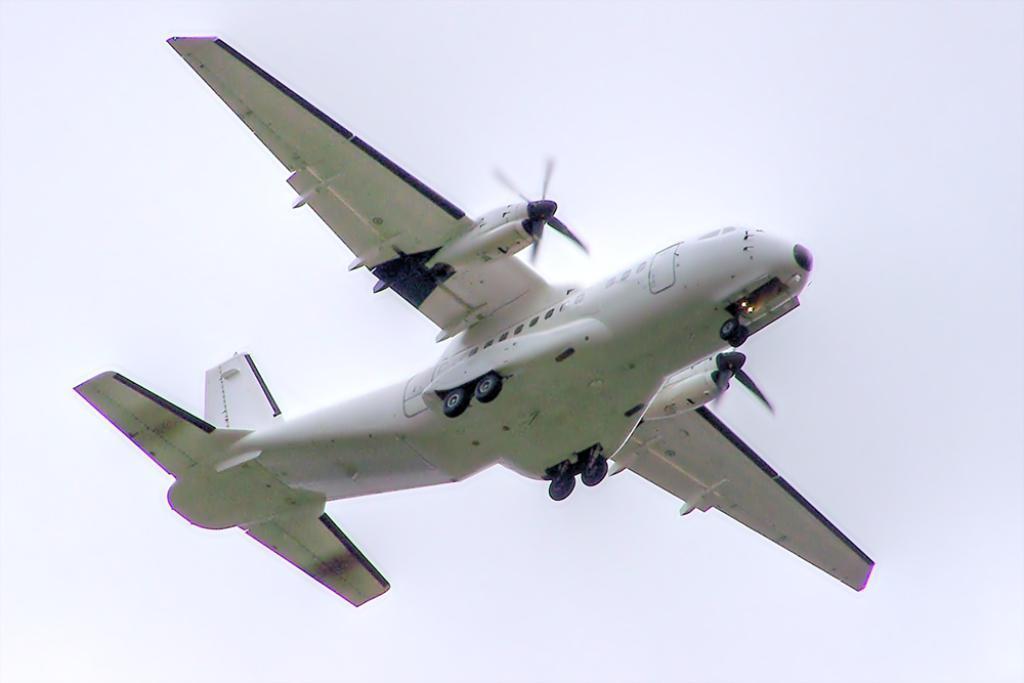Please provide a concise description of this image. In this image I can see a plane, in the air and background is white. 